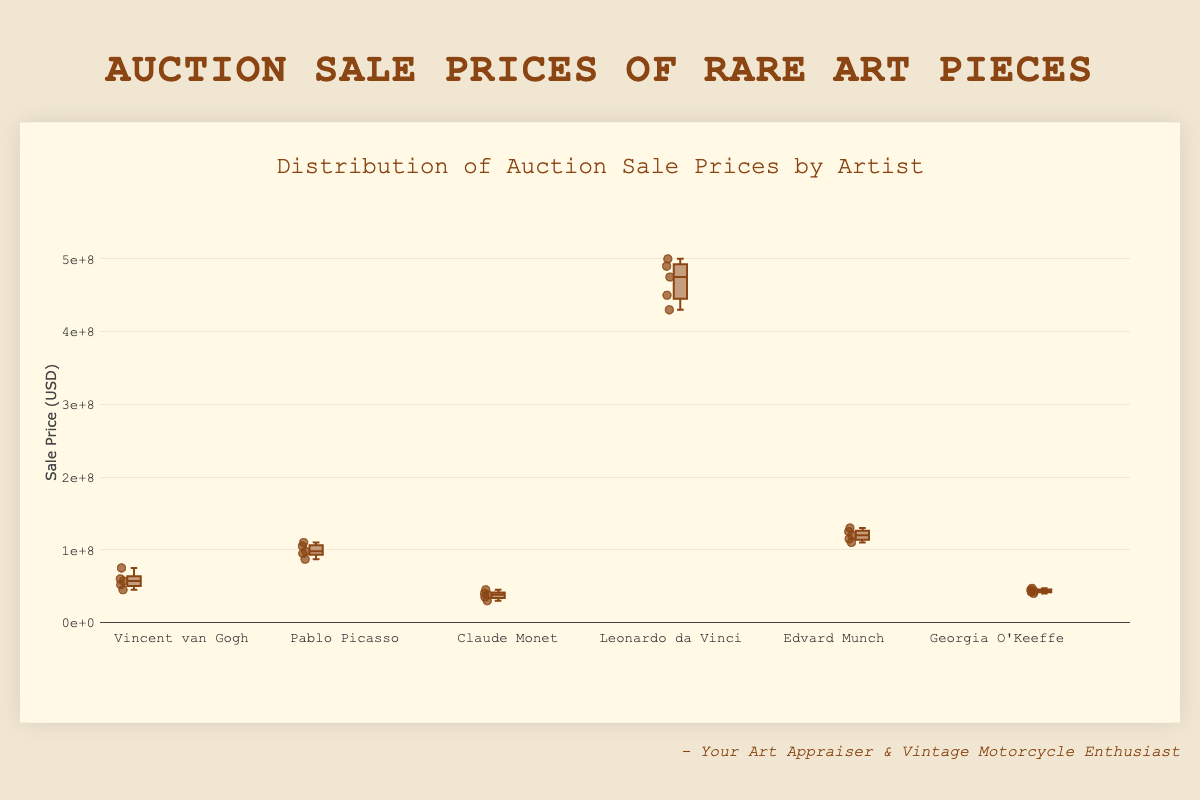How many artists' sale prices are displayed in the figure? The figure contains a box plot for each artist, and you can count the number of distinct box plots to determine the number of artists. Six names are listed: Vincent van Gogh, Pablo Picasso, Claude Monet, Leonardo da Vinci, Edvard Munch, and Georgia O'Keeffe.
Answer: Six What is the highest recorded sale price for Leonardo da Vinci's artworks? Identify the top whisker or the highest point in the box plot for Leonardo da Vinci, which represents the maximum sale price recorded. The highest value is marked at $500,000,000.
Answer: $500,000,000 Which artist has the lowest median sale price? Locate the median line within each box plot for all artists. Compare their positions on the y-axis, where the median for Claude Monet is at $380,000,000, which is the lowest among all medians.
Answer: Claude Monet What range is covered by the interquartile range (IQR) for Pablo Picasso's artworks? The IQR is the range between the first quartile (Q1) and the third quartile (Q3) of a box plot. For Pablo Picasso, the lower and upper edges of the box are approximately at $95,000,000 and $110,000,000 respectively, giving an IQR of $110,000,000 - $95,000,000.
Answer: $15,000,000 Compare the sale prices for Vincent van Gogh and Georgia O'Keeffe. Which artist has higher prices overall? By visual inspection, compare the spread and highest values of the box plots. Vincent van Gogh's sale prices range from $45,000,000 to $75,000,000, while Georgia O'Keeffe's range from $40,000,000 to $47,000,000. Vincent van Gogh's prices are generally higher.
Answer: Vincent van Gogh What is the median sale price for Edvard Munch? The median is denoted by the line within the box. For Edvard Munch, this line is positioned around the $120,000,000 mark.
Answer: $120,000,000 Which artist has the widest range of sale prices? The widest range can be observed by looking at the distance between the minimum and maximum whiskers of the box plots. Leonardo da Vinci has the widest range, from $430,000,000 to $500,000,000.
Answer: Leonardo da Vinci What's the average sale price for Claude Monet's artworks? To find the average, sum up Claude Monet's sale prices ($30,000,000 + $35,000,000 + $40,000,000 + $45,000,000 + $38,000,000) and divide by the number of prices. The average is ($188,000,000 / 5).
Answer: $37,600,000 How does the variability in sale prices for Georgia O'Keeffe compare to that for Vincent van Gogh? Compare the interquartile ranges and overall spread of the prices. Georgia O'Keeffe's IQR is smaller than Vincent van Gogh's, indicating less variability compared to Vincent van Gogh.
Answer: Georgia O'Keeffe shows less variability Which artist's artworks have the most closely grouped sale prices? To determine this, compare the boxes' tightness and the range of whiskers. Claude Monet's box plot is the closest, indicating the sale prices are more closely grouped together.
Answer: Claude Monet 